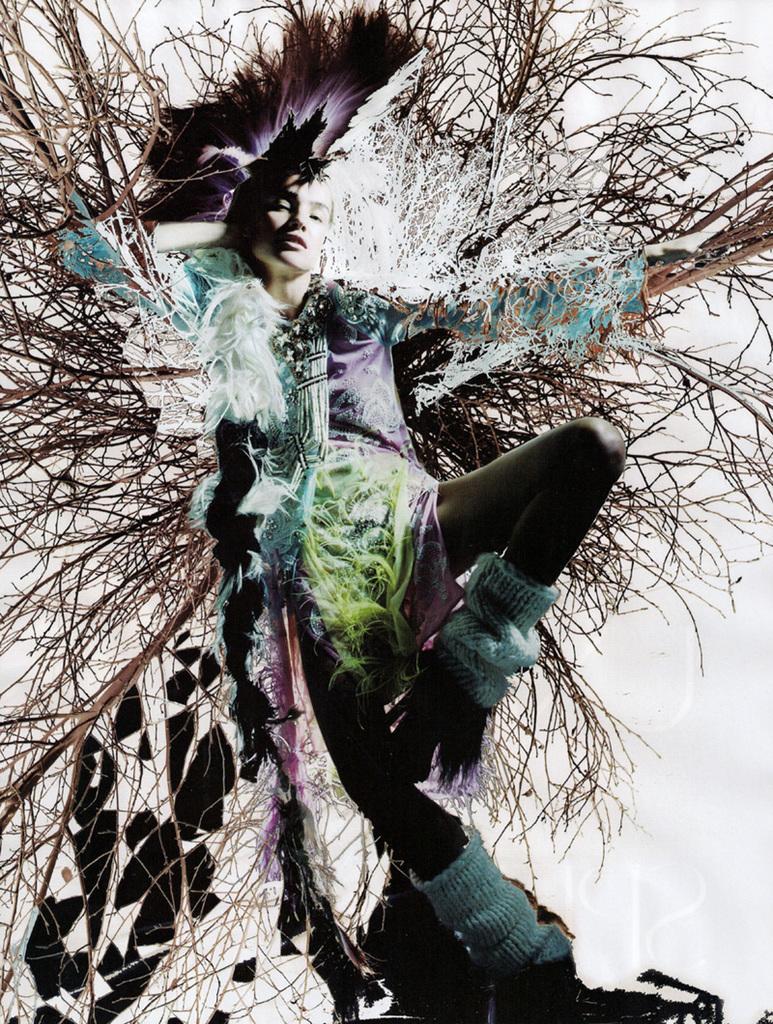Can you describe this image briefly? In this picture I can see there is a woman standing and she is wearing a colorful dress and she is wearing a hat, it has few feathers and in the backdrop, I can see there are few twigs and branches of a tree and there is a white wall behind it. 